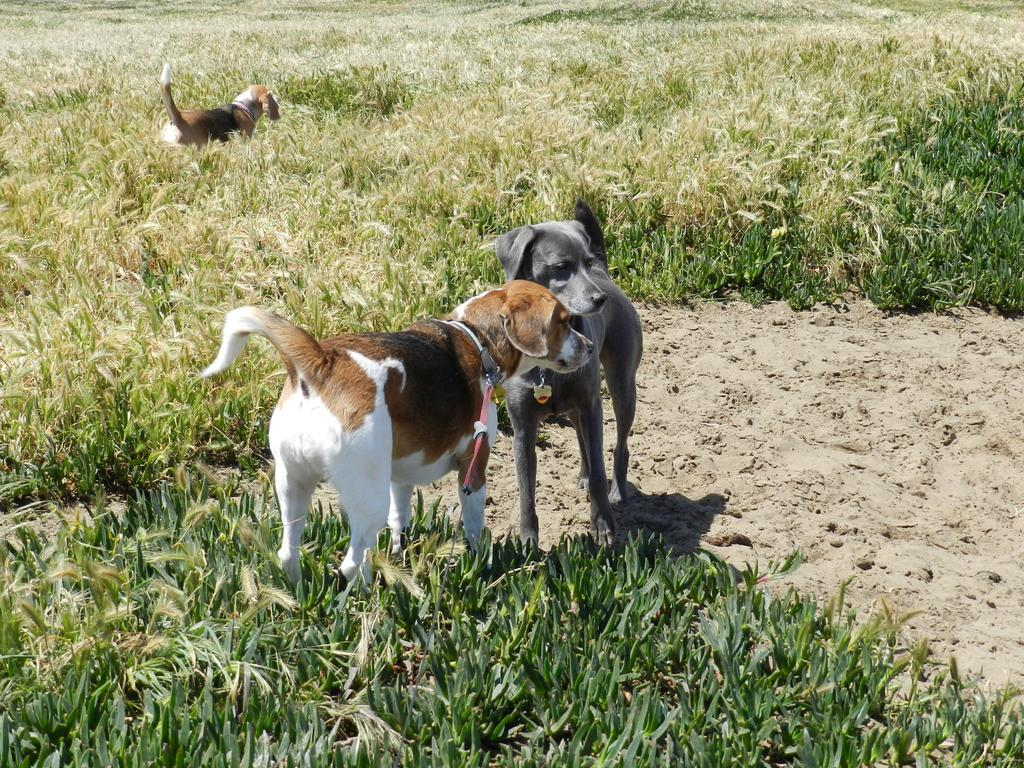What animals are in the center of the image? There are two dogs in the center of the image. What is the texture of the area where the dogs are? There is a muddy texture in the image. What type of environment is visible in the image? There is grassland in the image. Are there any other dogs in the image? Yes, there is another dog at the top side of the image. What color is the sock worn by the father in the image? There is no sock or father present in the image; it features two dogs and another dog in a grassland environment with a muddy texture. 